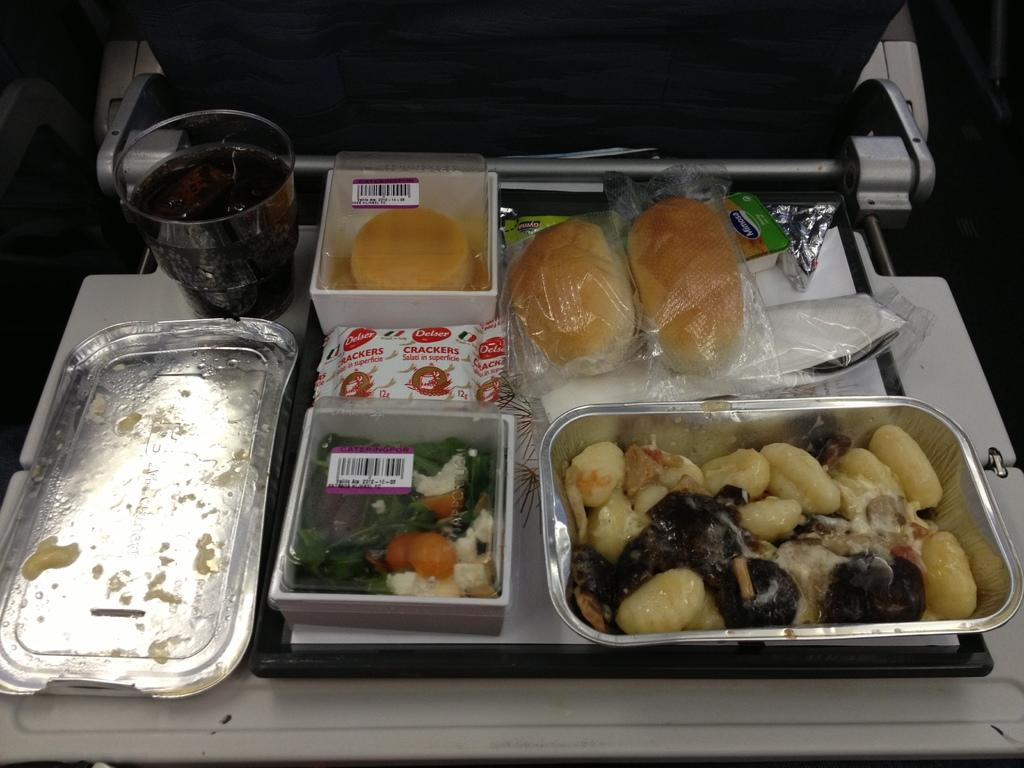What is the main object on which other items are placed in the image? There is a tray in the image. What types of items are on the tray? There are boxes, covers, and packets on the tray. What can be seen on the left side of the image? There is a glass of drink on the left side of the image. What is inside the boxes on the tray? There is food present in the boxes. How many spiders are crawling on the neck of the giraffe in the image? There are no spiders or giraffes present in the image. 